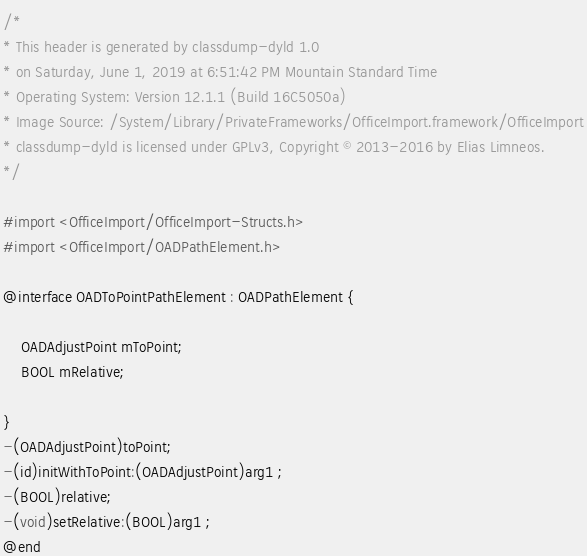Convert code to text. <code><loc_0><loc_0><loc_500><loc_500><_C_>/*
* This header is generated by classdump-dyld 1.0
* on Saturday, June 1, 2019 at 6:51:42 PM Mountain Standard Time
* Operating System: Version 12.1.1 (Build 16C5050a)
* Image Source: /System/Library/PrivateFrameworks/OfficeImport.framework/OfficeImport
* classdump-dyld is licensed under GPLv3, Copyright © 2013-2016 by Elias Limneos.
*/

#import <OfficeImport/OfficeImport-Structs.h>
#import <OfficeImport/OADPathElement.h>

@interface OADToPointPathElement : OADPathElement {

	OADAdjustPoint mToPoint;
	BOOL mRelative;

}
-(OADAdjustPoint)toPoint;
-(id)initWithToPoint:(OADAdjustPoint)arg1 ;
-(BOOL)relative;
-(void)setRelative:(BOOL)arg1 ;
@end

</code> 